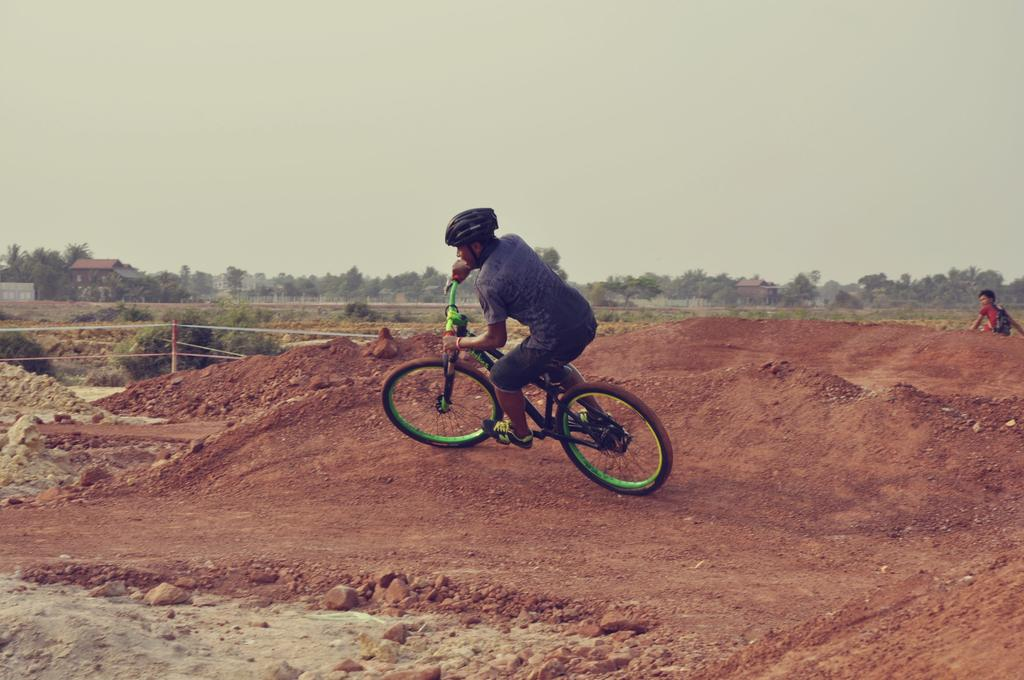What can be seen in the background of the image? There is a sky in the image. What type of structure is present in the image? There is a building in the image. What type of vegetation is visible in the image? There are trees in the image. What activity is the man in the image engaged in? There is a man riding a bicycle in the image. What type of butter is being used to control the knowledge in the image? There is no butter, control, or knowledge present in the image. 